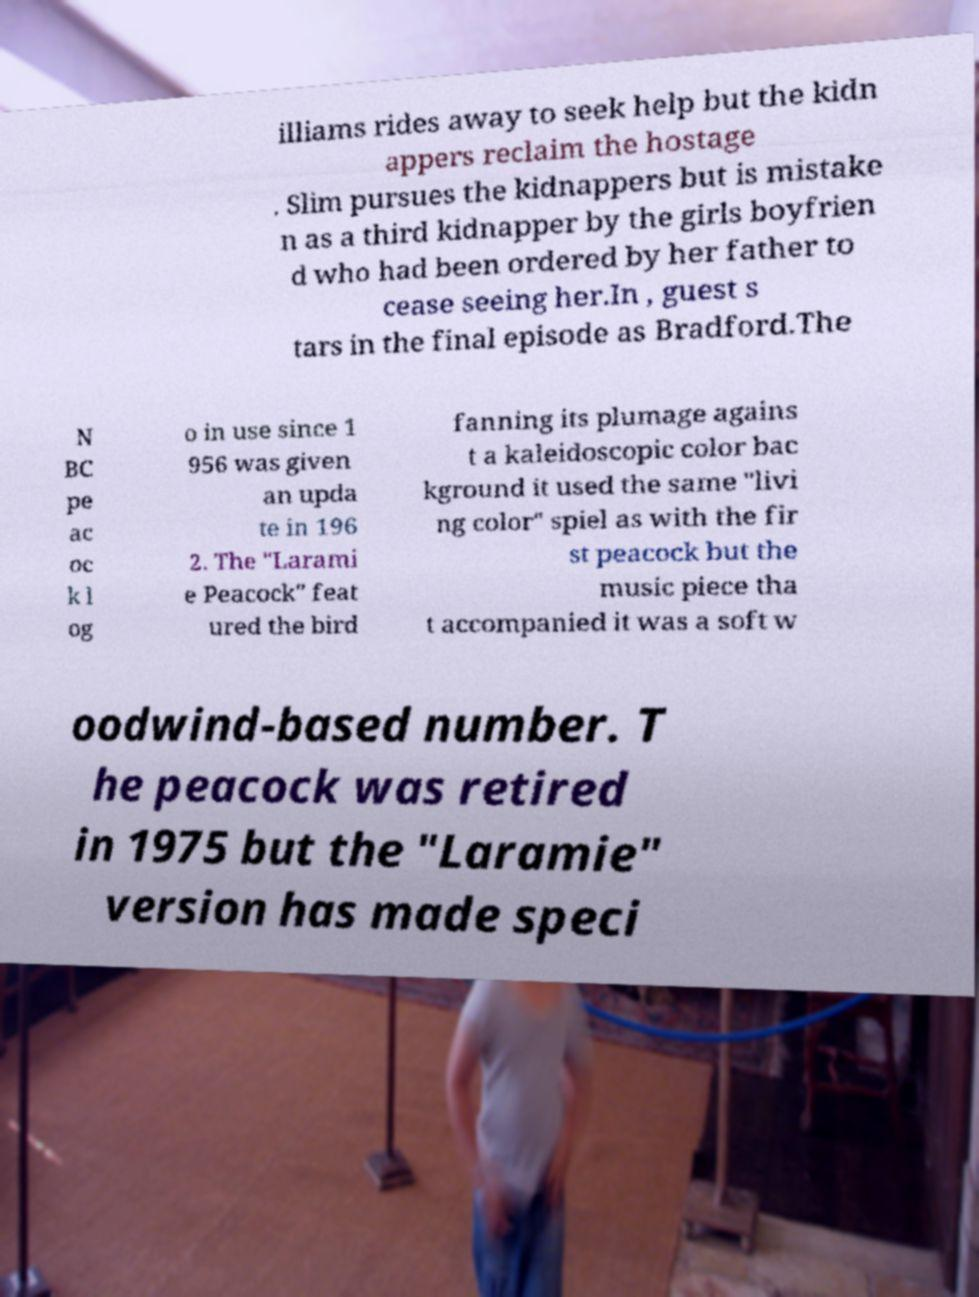Could you assist in decoding the text presented in this image and type it out clearly? illiams rides away to seek help but the kidn appers reclaim the hostage . Slim pursues the kidnappers but is mistake n as a third kidnapper by the girls boyfrien d who had been ordered by her father to cease seeing her.In , guest s tars in the final episode as Bradford.The N BC pe ac oc k l og o in use since 1 956 was given an upda te in 196 2. The "Larami e Peacock" feat ured the bird fanning its plumage agains t a kaleidoscopic color bac kground it used the same "livi ng color" spiel as with the fir st peacock but the music piece tha t accompanied it was a soft w oodwind-based number. T he peacock was retired in 1975 but the "Laramie" version has made speci 